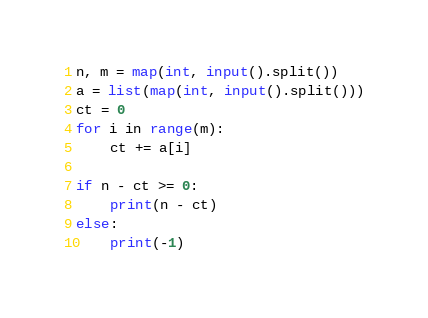<code> <loc_0><loc_0><loc_500><loc_500><_Python_>n, m = map(int, input().split())
a = list(map(int, input().split()))
ct = 0
for i in range(m):
    ct += a[i]

if n - ct >= 0:
    print(n - ct)
else:
    print(-1)
</code> 